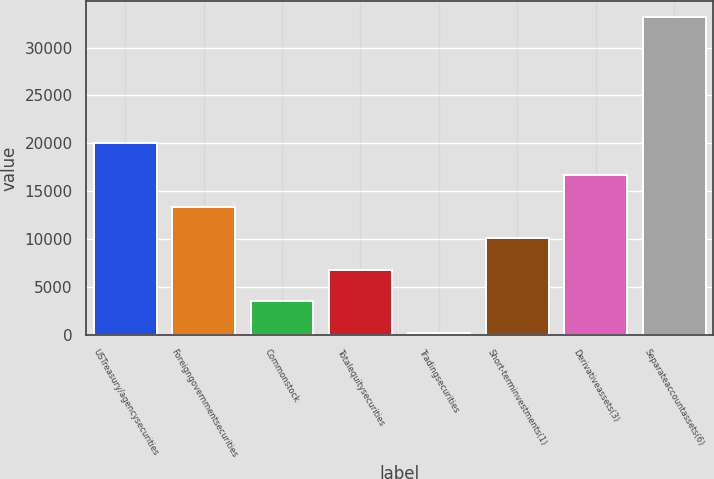<chart> <loc_0><loc_0><loc_500><loc_500><bar_chart><fcel>USTreasury/agencysecurities<fcel>Foreigngovernmentsecurities<fcel>Commonstock<fcel>Totalequitysecurities<fcel>Tradingsecurities<fcel>Short-terminvestments(1)<fcel>Derivativeassets(3)<fcel>Separateaccountassets(6)<nl><fcel>19990.6<fcel>13388.4<fcel>3485.1<fcel>6786.2<fcel>184<fcel>10087.3<fcel>16689.5<fcel>33195<nl></chart> 